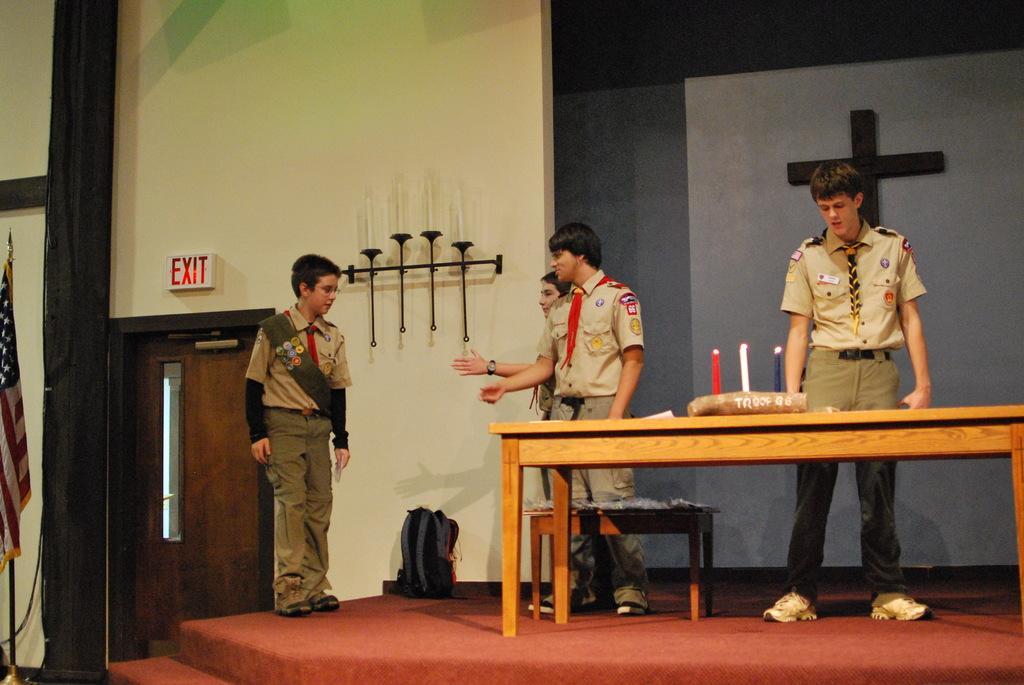Can you describe this image briefly? In this image there is a stage on which there is a table. There are few students standing near the table. On the table there are three candles. To the left side there is a flag and a door beside it. There is a exit board which is on the top of door. 